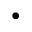Convert formula to latex. <formula><loc_0><loc_0><loc_500><loc_500>\bullet</formula> 